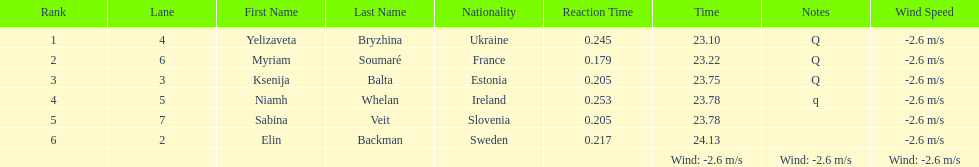What number of last names start with "b"? 3. 